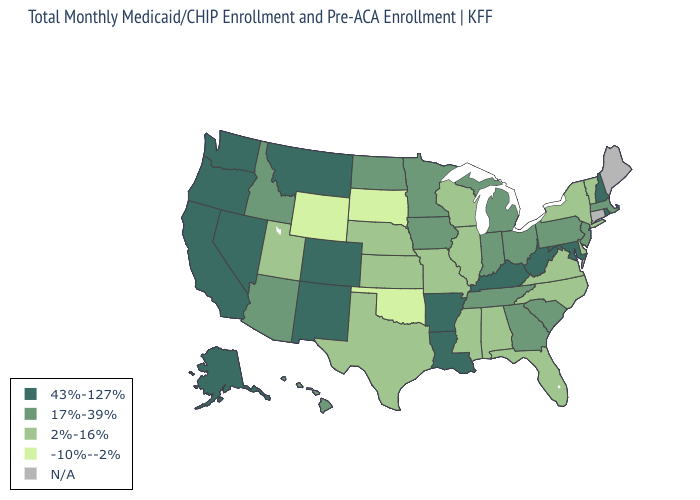Does Florida have the lowest value in the USA?
Write a very short answer. No. Does Rhode Island have the highest value in the USA?
Quick response, please. Yes. Name the states that have a value in the range -10%--2%?
Be succinct. Oklahoma, South Dakota, Wyoming. Does Louisiana have the highest value in the USA?
Keep it brief. Yes. Name the states that have a value in the range 2%-16%?
Short answer required. Alabama, Delaware, Florida, Illinois, Kansas, Mississippi, Missouri, Nebraska, New York, North Carolina, Texas, Utah, Vermont, Virginia, Wisconsin. What is the highest value in the USA?
Write a very short answer. 43%-127%. What is the value of New Jersey?
Give a very brief answer. 17%-39%. Does South Carolina have the lowest value in the USA?
Concise answer only. No. What is the value of Louisiana?
Be succinct. 43%-127%. What is the lowest value in states that border South Dakota?
Concise answer only. -10%--2%. Among the states that border New York , does New Jersey have the highest value?
Quick response, please. Yes. Does Rhode Island have the highest value in the Northeast?
Short answer required. Yes. Which states hav the highest value in the MidWest?
Keep it brief. Indiana, Iowa, Michigan, Minnesota, North Dakota, Ohio. Among the states that border West Virginia , does Maryland have the highest value?
Concise answer only. Yes. What is the value of Florida?
Give a very brief answer. 2%-16%. 